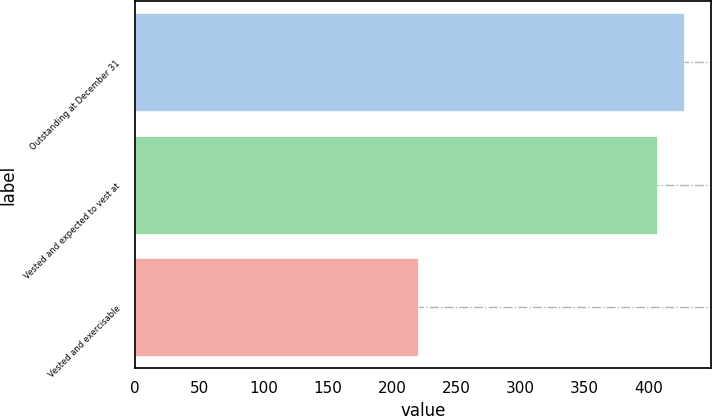Convert chart to OTSL. <chart><loc_0><loc_0><loc_500><loc_500><bar_chart><fcel>Outstanding at December 31<fcel>Vested and expected to vest at<fcel>Vested and exercisable<nl><fcel>427<fcel>406<fcel>220<nl></chart> 